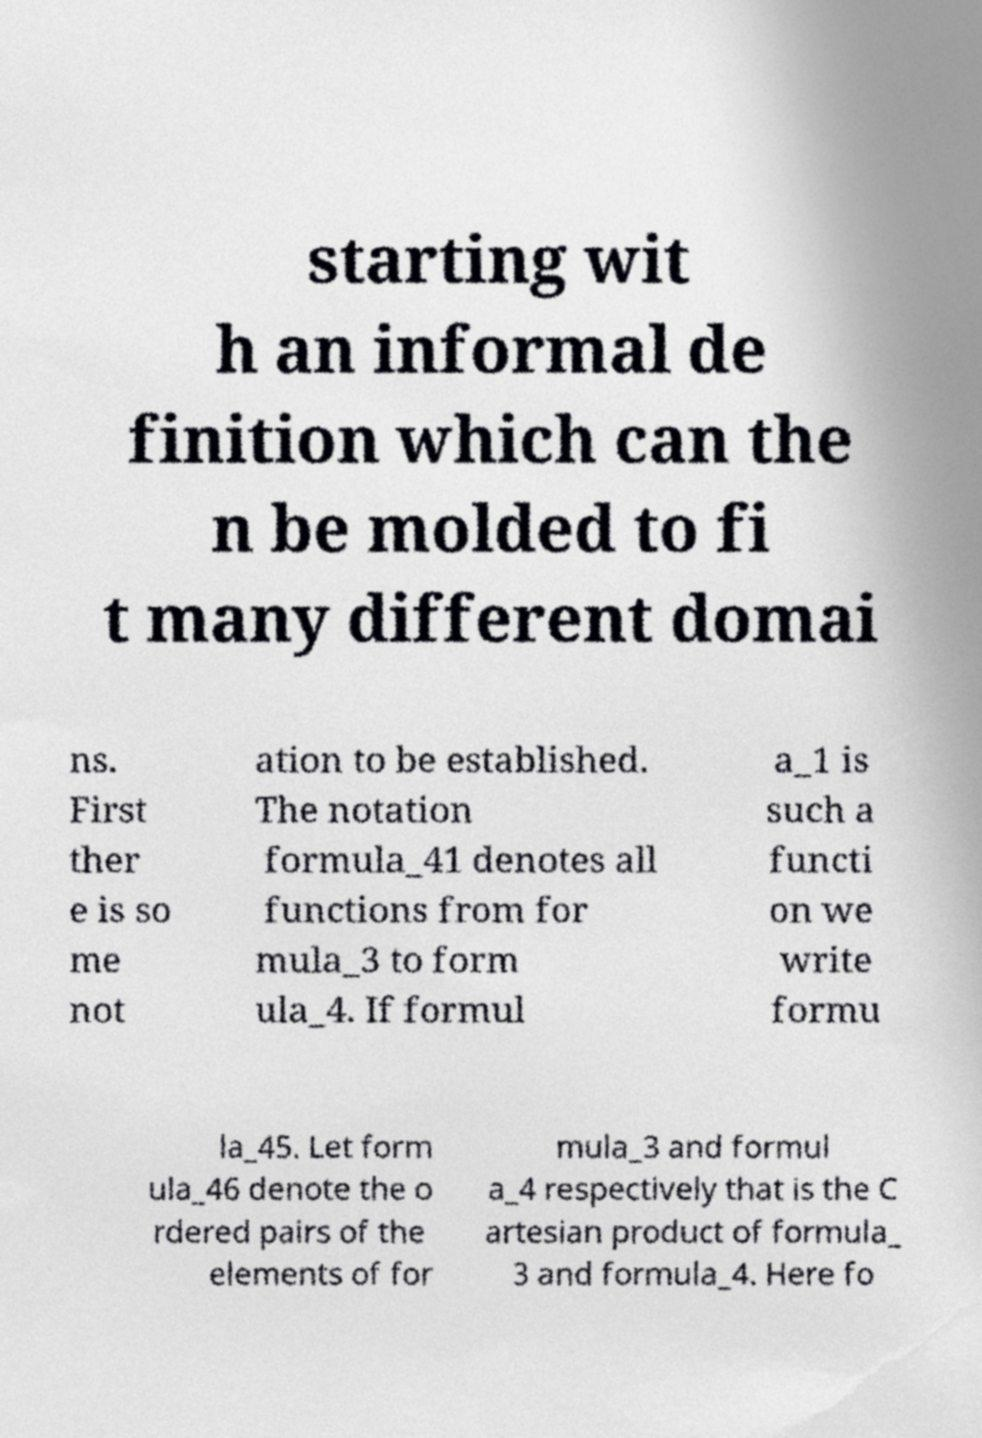Could you extract and type out the text from this image? starting wit h an informal de finition which can the n be molded to fi t many different domai ns. First ther e is so me not ation to be established. The notation formula_41 denotes all functions from for mula_3 to form ula_4. If formul a_1 is such a functi on we write formu la_45. Let form ula_46 denote the o rdered pairs of the elements of for mula_3 and formul a_4 respectively that is the C artesian product of formula_ 3 and formula_4. Here fo 